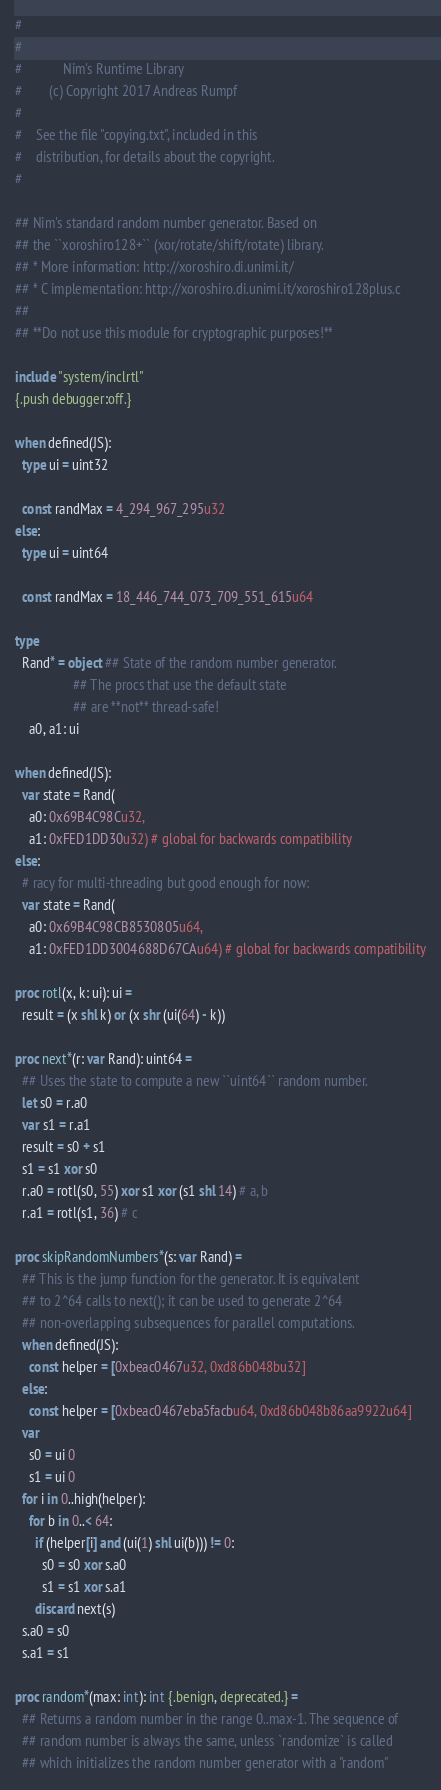Convert code to text. <code><loc_0><loc_0><loc_500><loc_500><_Nim_>#
#
#            Nim's Runtime Library
#        (c) Copyright 2017 Andreas Rumpf
#
#    See the file "copying.txt", included in this
#    distribution, for details about the copyright.
#

## Nim's standard random number generator. Based on
## the ``xoroshiro128+`` (xor/rotate/shift/rotate) library.
## * More information: http://xoroshiro.di.unimi.it/
## * C implementation: http://xoroshiro.di.unimi.it/xoroshiro128plus.c
##
## **Do not use this module for cryptographic purposes!**

include "system/inclrtl"
{.push debugger:off.}

when defined(JS):
  type ui = uint32

  const randMax = 4_294_967_295u32
else:
  type ui = uint64

  const randMax = 18_446_744_073_709_551_615u64

type
  Rand* = object ## State of the random number generator.
                 ## The procs that use the default state
                 ## are **not** thread-safe!
    a0, a1: ui

when defined(JS):
  var state = Rand(
    a0: 0x69B4C98Cu32,
    a1: 0xFED1DD30u32) # global for backwards compatibility
else:
  # racy for multi-threading but good enough for now:
  var state = Rand(
    a0: 0x69B4C98CB8530805u64,
    a1: 0xFED1DD3004688D67CAu64) # global for backwards compatibility

proc rotl(x, k: ui): ui =
  result = (x shl k) or (x shr (ui(64) - k))

proc next*(r: var Rand): uint64 =
  ## Uses the state to compute a new ``uint64`` random number.
  let s0 = r.a0
  var s1 = r.a1
  result = s0 + s1
  s1 = s1 xor s0
  r.a0 = rotl(s0, 55) xor s1 xor (s1 shl 14) # a, b
  r.a1 = rotl(s1, 36) # c

proc skipRandomNumbers*(s: var Rand) =
  ## This is the jump function for the generator. It is equivalent
  ## to 2^64 calls to next(); it can be used to generate 2^64
  ## non-overlapping subsequences for parallel computations.
  when defined(JS):
    const helper = [0xbeac0467u32, 0xd86b048bu32]
  else:
    const helper = [0xbeac0467eba5facbu64, 0xd86b048b86aa9922u64]
  var
    s0 = ui 0
    s1 = ui 0
  for i in 0..high(helper):
    for b in 0..< 64:
      if (helper[i] and (ui(1) shl ui(b))) != 0:
        s0 = s0 xor s.a0
        s1 = s1 xor s.a1
      discard next(s)
  s.a0 = s0
  s.a1 = s1

proc random*(max: int): int {.benign, deprecated.} =
  ## Returns a random number in the range 0..max-1. The sequence of
  ## random number is always the same, unless `randomize` is called
  ## which initializes the random number generator with a "random"</code> 